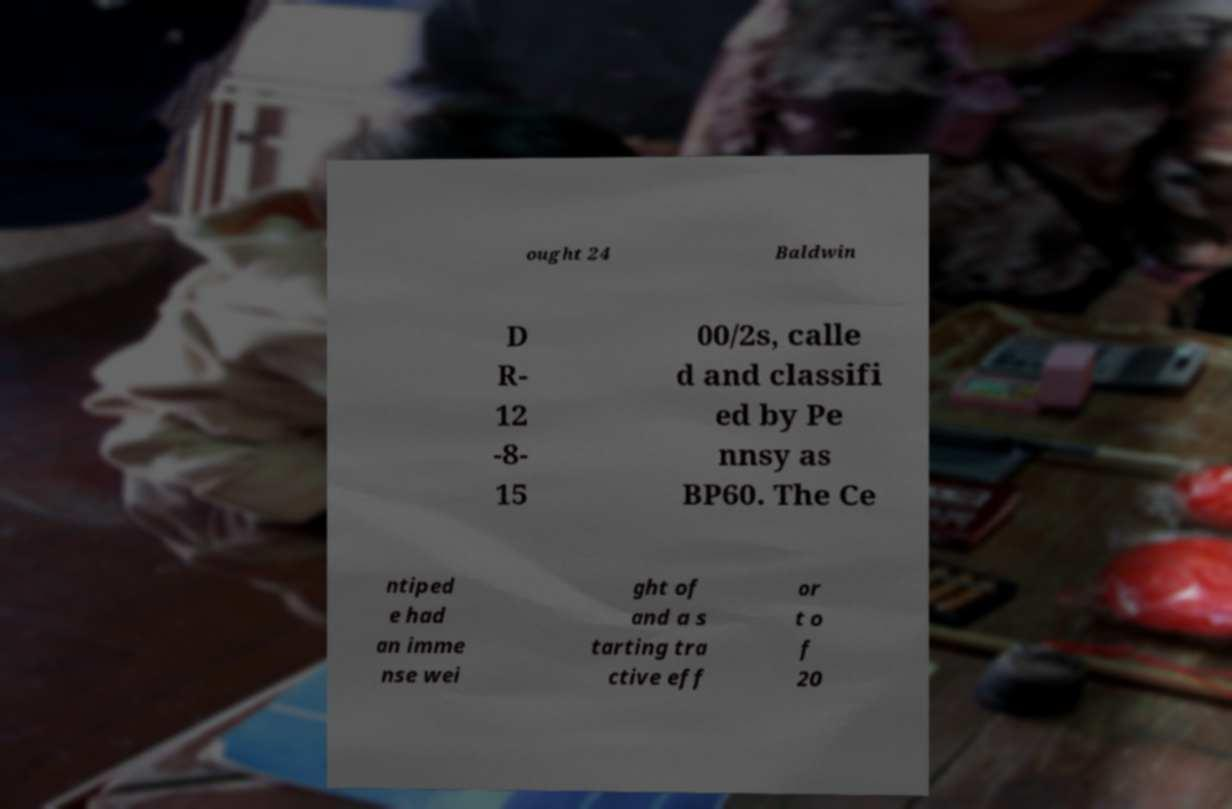For documentation purposes, I need the text within this image transcribed. Could you provide that? ought 24 Baldwin D R- 12 -8- 15 00/2s, calle d and classifi ed by Pe nnsy as BP60. The Ce ntiped e had an imme nse wei ght of and a s tarting tra ctive eff or t o f 20 